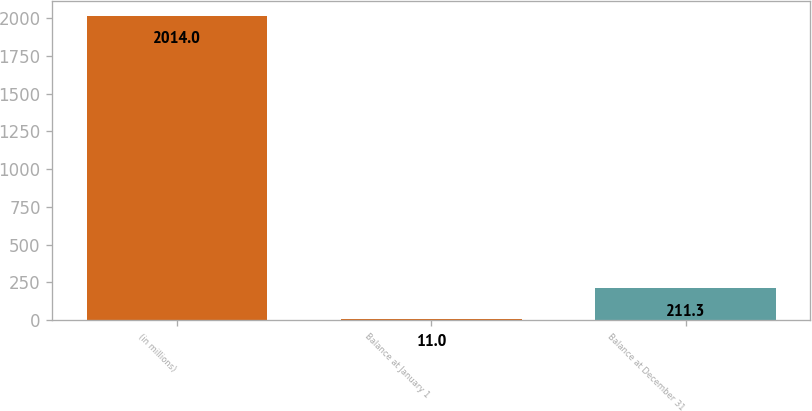<chart> <loc_0><loc_0><loc_500><loc_500><bar_chart><fcel>(in millions)<fcel>Balance at January 1<fcel>Balance at December 31<nl><fcel>2014<fcel>11<fcel>211.3<nl></chart> 